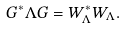<formula> <loc_0><loc_0><loc_500><loc_500>G ^ { * } \Lambda G = W _ { \Lambda } ^ { * } W _ { \Lambda } .</formula> 